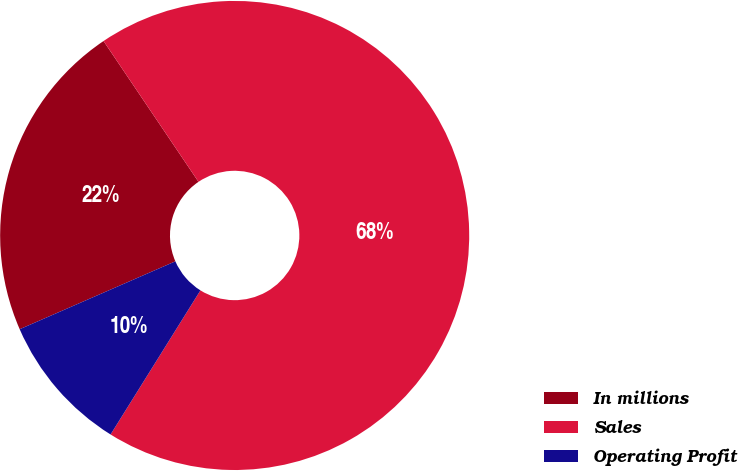Convert chart to OTSL. <chart><loc_0><loc_0><loc_500><loc_500><pie_chart><fcel>In millions<fcel>Sales<fcel>Operating Profit<nl><fcel>22.1%<fcel>68.31%<fcel>9.58%<nl></chart> 